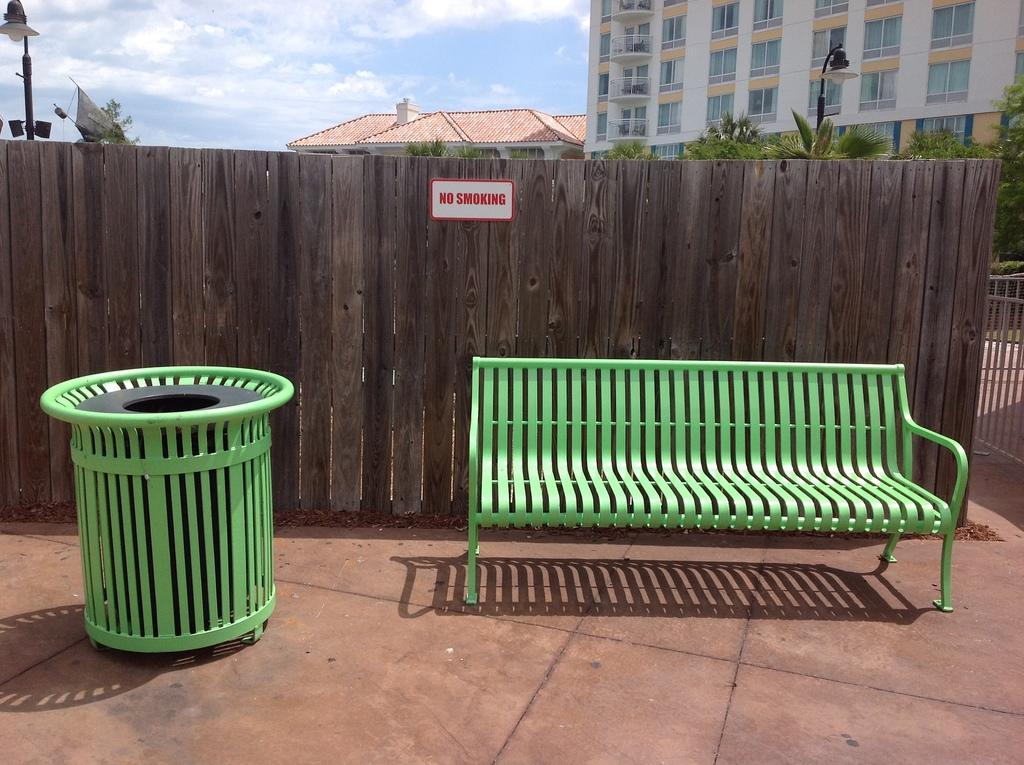How would you summarize this image in a sentence or two? This image is clicked outside. There is a bench on the right side. There is dustbin on the left side. There are trees in the middle. There is a building at the top. There is sky at the top. 